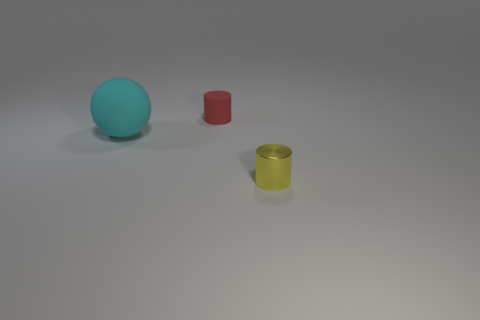Is there any other thing that is the same size as the cyan rubber object?
Provide a succinct answer. No. Is there anything else that has the same material as the yellow cylinder?
Keep it short and to the point. No. How many metal things are small cylinders or small yellow cylinders?
Make the answer very short. 1. Are there any things that have the same material as the tiny red cylinder?
Provide a succinct answer. Yes. How many things are both in front of the rubber cylinder and behind the yellow metal cylinder?
Offer a very short reply. 1. Are there fewer yellow metallic things that are behind the large cyan sphere than cyan rubber balls behind the red object?
Offer a terse response. No. Is the shape of the red matte thing the same as the cyan object?
Offer a terse response. No. How many other things are there of the same size as the ball?
Your response must be concise. 0. How many things are either tiny objects right of the red rubber cylinder or rubber things that are on the left side of the red cylinder?
Your response must be concise. 2. How many other matte objects are the same shape as the tiny yellow thing?
Offer a terse response. 1. 